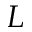<formula> <loc_0><loc_0><loc_500><loc_500>L</formula> 